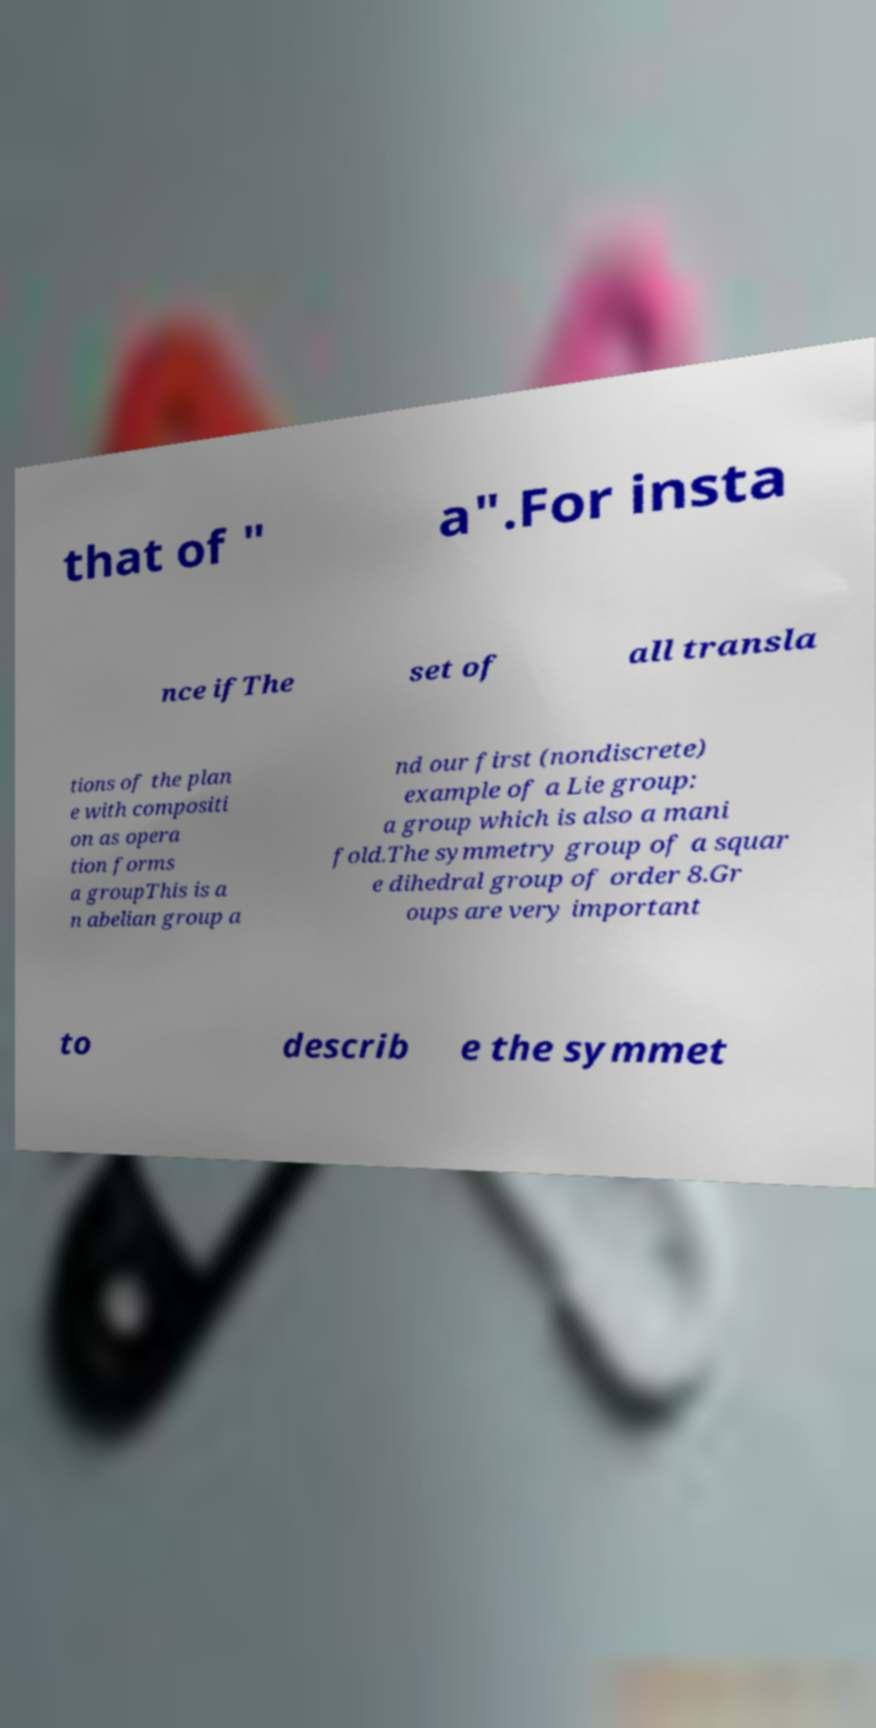Please identify and transcribe the text found in this image. that of " a".For insta nce ifThe set of all transla tions of the plan e with compositi on as opera tion forms a groupThis is a n abelian group a nd our first (nondiscrete) example of a Lie group: a group which is also a mani fold.The symmetry group of a squar e dihedral group of order 8.Gr oups are very important to describ e the symmet 